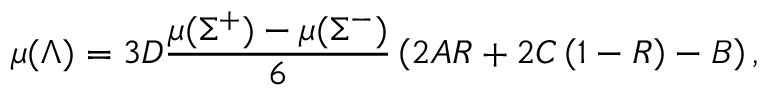<formula> <loc_0><loc_0><loc_500><loc_500>\mu ( \Lambda ) = 3 D \frac { \mu ( \Sigma ^ { + } ) - \mu ( \Sigma ^ { - } ) } { 6 } \left ( 2 A R + 2 C \left ( 1 - R \right ) - B \right ) ,</formula> 